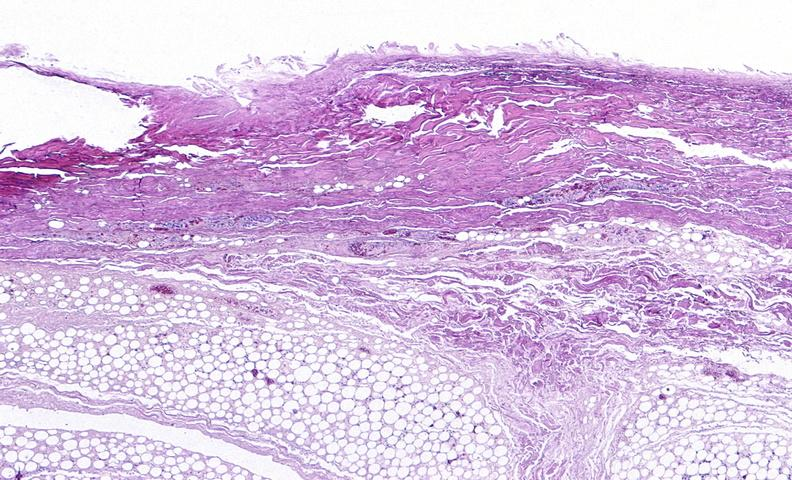does interstitial cell tumor show panniculitis and fascitis?
Answer the question using a single word or phrase. No 